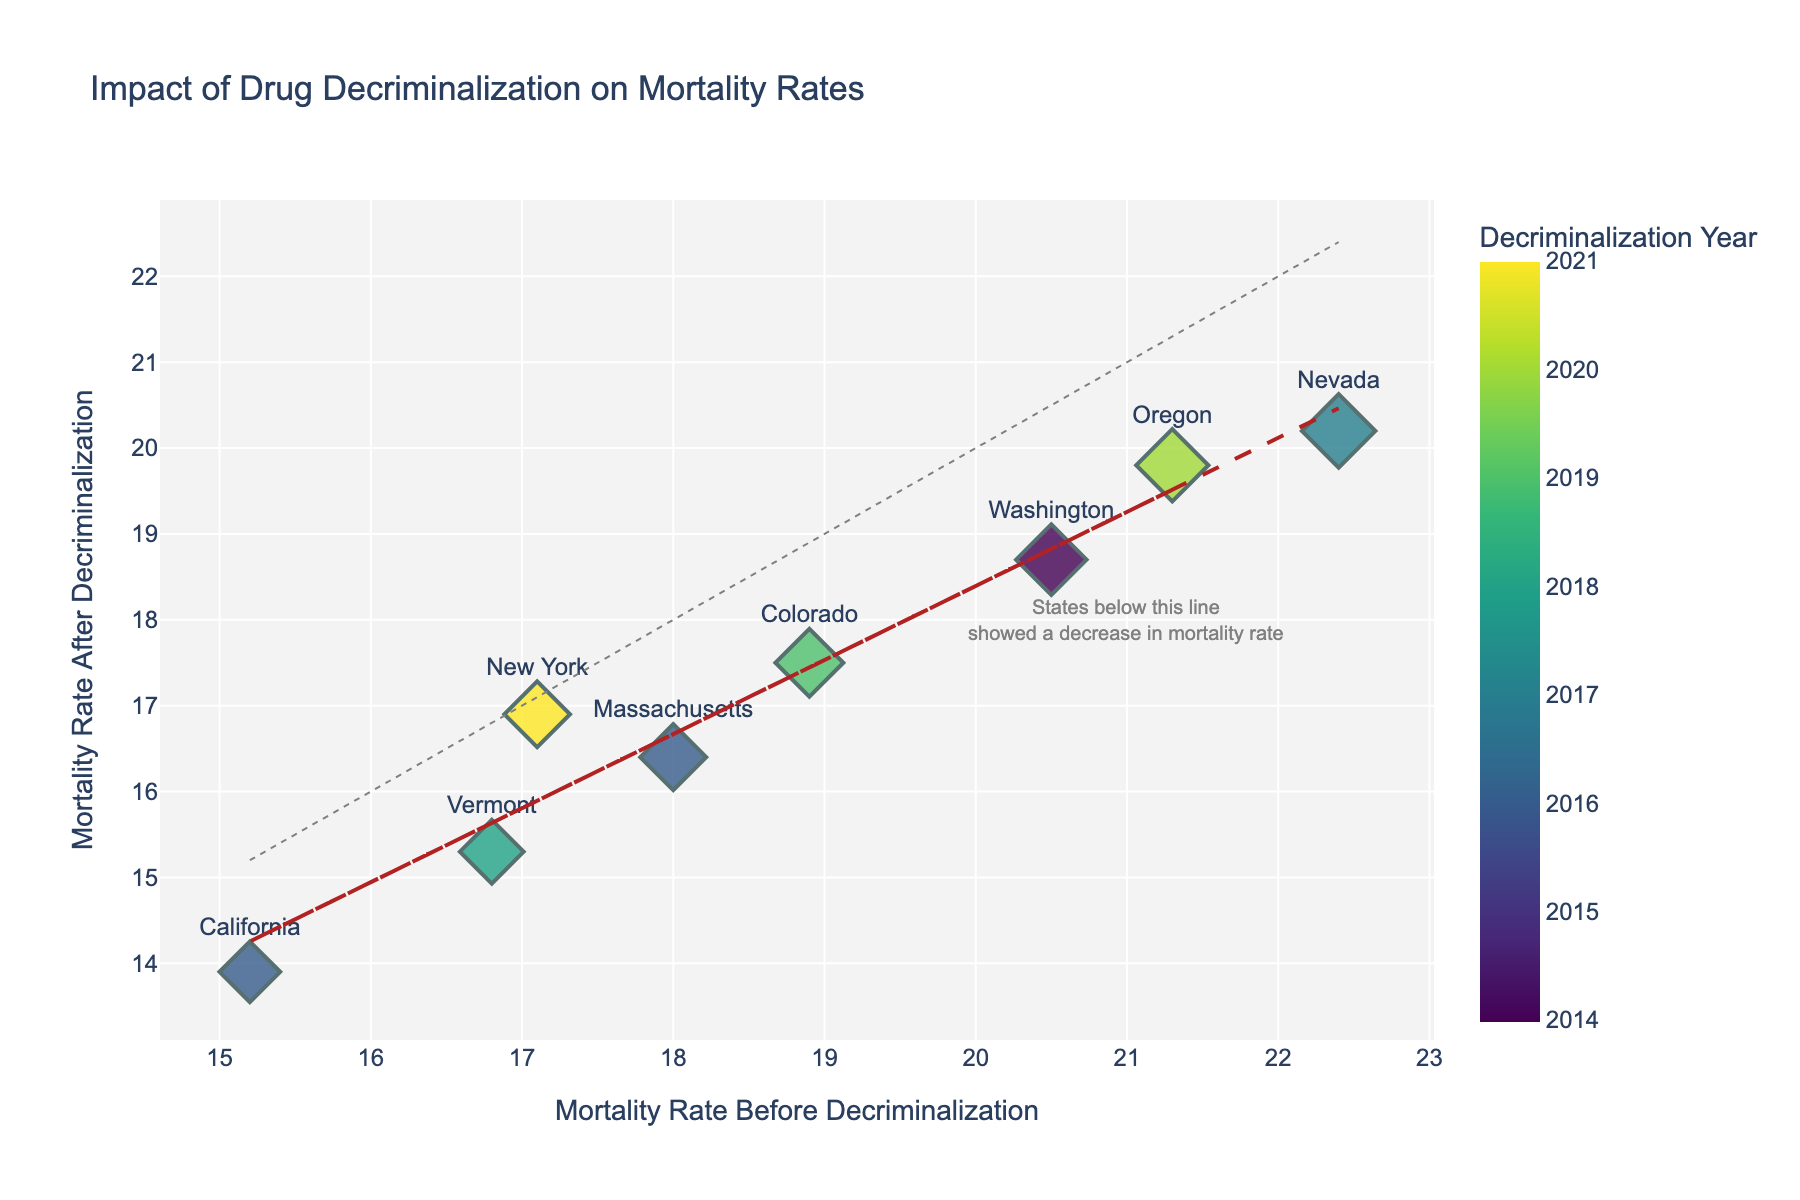Which state had the largest decrease in drug-related mortality rate after decriminalization? To find the state with the largest decrease, we subtract the "Drug-Related Mortality Rate (After)" from the "Drug-Related Mortality Rate (Before)" for each state and compare the differences. The state with the largest positive difference will be the answer.
Answer: Nevada What's the trend shown by the trend line in the scatter plot? The trend line's slope indicates the overall relation between mortality rates before and after decriminalization. If the slope is less than one, it suggests that, on average, the mortality rate decreased after decriminalization.
Answer: Decreasing trend Which state has the highest drug-related mortality rate after decriminalization? To find this, we need to identify the state with the highest value in the "Drug-Related Mortality Rate (After)" column.
Answer: Nevada How many states showed a decrease in drug-related mortality rate after decriminalization? By examining the scatter plot and identifying which data points are below the reference line y=x, we can count the number of states that experienced a decrease.
Answer: Seven states Which state had the smallest change in drug-related mortality rate after decriminalization? To determine the state with the smallest change, we calculate the absolute difference between "Drug-Related Mortality Rate (Before)" and "Drug-Related Mortality Rate (After)" for each state and identify the smallest difference.
Answer: New York Is there any state that showed an increase in drug-related mortality rate after decriminalization? We examine the scatter plot to see if any data points lie above the reference line y=x, which would indicate an increase in mortality rate after decriminalization.
Answer: No What does it mean if a state's data point lies exactly on the reference line y=x? If a data point lies on the line y=x, it indicates that there was no change in the drug-related mortality rate before and after decriminalization for that state.
Answer: No change in mortality rate Which state had the lowest mortality rate before decriminalization, and what was the rate? By inspecting the "Drug-Related Mortality Rate (Before)" column, we find the state with the lowest value.
Answer: California, 15.2 What is the average mortality rate before decriminalization across all states? To determine this, we sum all the "Drug-Related Mortality Rate (Before)" values and divide by the number of states.
Answer: 18.5 Which state decriminalized drugs most recently, and in what year? By looking at the "Decriminalization Year" column, we can identify the state with the most recent year.
Answer: New York, 2021 